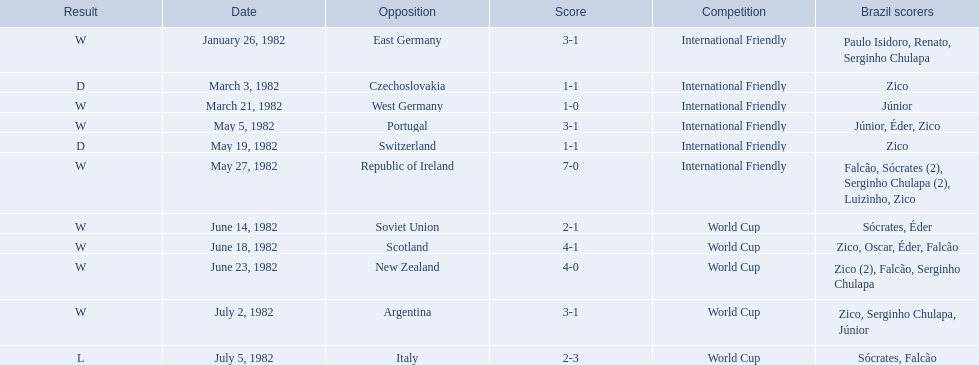What are the dates January 26, 1982, March 3, 1982, March 21, 1982, May 5, 1982, May 19, 1982, May 27, 1982, June 14, 1982, June 18, 1982, June 23, 1982, July 2, 1982, July 5, 1982. Which date is at the top? January 26, 1982. 